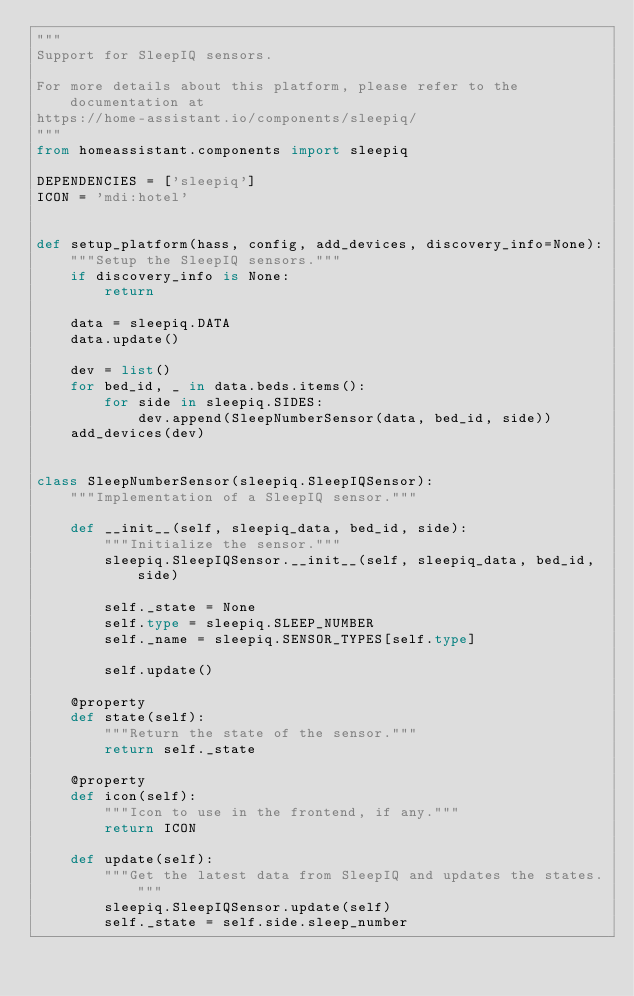Convert code to text. <code><loc_0><loc_0><loc_500><loc_500><_Python_>"""
Support for SleepIQ sensors.

For more details about this platform, please refer to the documentation at
https://home-assistant.io/components/sleepiq/
"""
from homeassistant.components import sleepiq

DEPENDENCIES = ['sleepiq']
ICON = 'mdi:hotel'


def setup_platform(hass, config, add_devices, discovery_info=None):
    """Setup the SleepIQ sensors."""
    if discovery_info is None:
        return

    data = sleepiq.DATA
    data.update()

    dev = list()
    for bed_id, _ in data.beds.items():
        for side in sleepiq.SIDES:
            dev.append(SleepNumberSensor(data, bed_id, side))
    add_devices(dev)


class SleepNumberSensor(sleepiq.SleepIQSensor):
    """Implementation of a SleepIQ sensor."""

    def __init__(self, sleepiq_data, bed_id, side):
        """Initialize the sensor."""
        sleepiq.SleepIQSensor.__init__(self, sleepiq_data, bed_id, side)

        self._state = None
        self.type = sleepiq.SLEEP_NUMBER
        self._name = sleepiq.SENSOR_TYPES[self.type]

        self.update()

    @property
    def state(self):
        """Return the state of the sensor."""
        return self._state

    @property
    def icon(self):
        """Icon to use in the frontend, if any."""
        return ICON

    def update(self):
        """Get the latest data from SleepIQ and updates the states."""
        sleepiq.SleepIQSensor.update(self)
        self._state = self.side.sleep_number
</code> 